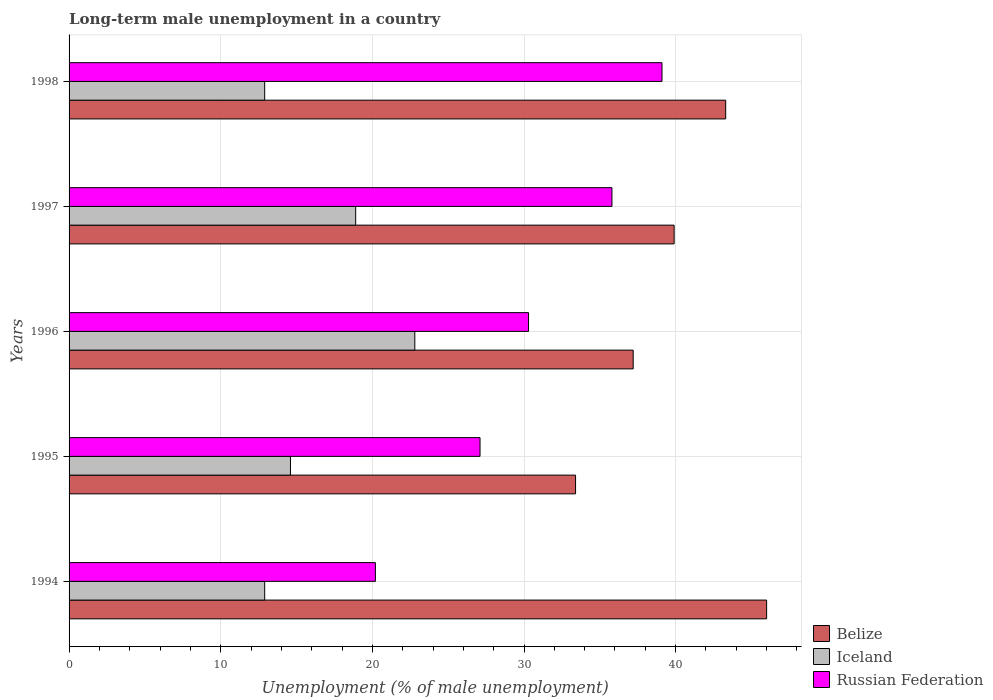How many different coloured bars are there?
Keep it short and to the point. 3. Are the number of bars per tick equal to the number of legend labels?
Offer a terse response. Yes. Are the number of bars on each tick of the Y-axis equal?
Make the answer very short. Yes. How many bars are there on the 5th tick from the top?
Your answer should be compact. 3. What is the percentage of long-term unemployed male population in Belize in 1997?
Offer a very short reply. 39.9. Across all years, what is the maximum percentage of long-term unemployed male population in Russian Federation?
Offer a very short reply. 39.1. Across all years, what is the minimum percentage of long-term unemployed male population in Iceland?
Give a very brief answer. 12.9. In which year was the percentage of long-term unemployed male population in Iceland maximum?
Provide a succinct answer. 1996. What is the total percentage of long-term unemployed male population in Iceland in the graph?
Your response must be concise. 82.1. What is the difference between the percentage of long-term unemployed male population in Russian Federation in 1994 and that in 1995?
Provide a succinct answer. -6.9. What is the difference between the percentage of long-term unemployed male population in Belize in 1994 and the percentage of long-term unemployed male population in Russian Federation in 1995?
Provide a succinct answer. 18.9. What is the average percentage of long-term unemployed male population in Belize per year?
Offer a terse response. 39.96. In the year 1994, what is the difference between the percentage of long-term unemployed male population in Belize and percentage of long-term unemployed male population in Russian Federation?
Offer a very short reply. 25.8. In how many years, is the percentage of long-term unemployed male population in Belize greater than 26 %?
Offer a terse response. 5. What is the ratio of the percentage of long-term unemployed male population in Belize in 1994 to that in 1995?
Keep it short and to the point. 1.38. Is the percentage of long-term unemployed male population in Iceland in 1994 less than that in 1998?
Provide a short and direct response. No. Is the difference between the percentage of long-term unemployed male population in Belize in 1996 and 1998 greater than the difference between the percentage of long-term unemployed male population in Russian Federation in 1996 and 1998?
Offer a terse response. Yes. What is the difference between the highest and the second highest percentage of long-term unemployed male population in Iceland?
Provide a succinct answer. 3.9. What is the difference between the highest and the lowest percentage of long-term unemployed male population in Belize?
Keep it short and to the point. 12.6. In how many years, is the percentage of long-term unemployed male population in Iceland greater than the average percentage of long-term unemployed male population in Iceland taken over all years?
Provide a succinct answer. 2. Is the sum of the percentage of long-term unemployed male population in Iceland in 1996 and 1997 greater than the maximum percentage of long-term unemployed male population in Russian Federation across all years?
Make the answer very short. Yes. What does the 1st bar from the top in 1997 represents?
Your answer should be compact. Russian Federation. Is it the case that in every year, the sum of the percentage of long-term unemployed male population in Belize and percentage of long-term unemployed male population in Russian Federation is greater than the percentage of long-term unemployed male population in Iceland?
Your answer should be very brief. Yes. Are all the bars in the graph horizontal?
Ensure brevity in your answer.  Yes. How many years are there in the graph?
Offer a terse response. 5. Does the graph contain any zero values?
Your answer should be compact. No. Where does the legend appear in the graph?
Keep it short and to the point. Bottom right. What is the title of the graph?
Provide a short and direct response. Long-term male unemployment in a country. Does "Guam" appear as one of the legend labels in the graph?
Provide a succinct answer. No. What is the label or title of the X-axis?
Provide a short and direct response. Unemployment (% of male unemployment). What is the label or title of the Y-axis?
Give a very brief answer. Years. What is the Unemployment (% of male unemployment) of Belize in 1994?
Offer a terse response. 46. What is the Unemployment (% of male unemployment) in Iceland in 1994?
Your answer should be very brief. 12.9. What is the Unemployment (% of male unemployment) in Russian Federation in 1994?
Offer a very short reply. 20.2. What is the Unemployment (% of male unemployment) in Belize in 1995?
Offer a very short reply. 33.4. What is the Unemployment (% of male unemployment) of Iceland in 1995?
Keep it short and to the point. 14.6. What is the Unemployment (% of male unemployment) in Russian Federation in 1995?
Provide a succinct answer. 27.1. What is the Unemployment (% of male unemployment) of Belize in 1996?
Your answer should be compact. 37.2. What is the Unemployment (% of male unemployment) of Iceland in 1996?
Offer a very short reply. 22.8. What is the Unemployment (% of male unemployment) in Russian Federation in 1996?
Keep it short and to the point. 30.3. What is the Unemployment (% of male unemployment) in Belize in 1997?
Make the answer very short. 39.9. What is the Unemployment (% of male unemployment) of Iceland in 1997?
Offer a terse response. 18.9. What is the Unemployment (% of male unemployment) of Russian Federation in 1997?
Your answer should be very brief. 35.8. What is the Unemployment (% of male unemployment) of Belize in 1998?
Ensure brevity in your answer.  43.3. What is the Unemployment (% of male unemployment) in Iceland in 1998?
Provide a short and direct response. 12.9. What is the Unemployment (% of male unemployment) in Russian Federation in 1998?
Make the answer very short. 39.1. Across all years, what is the maximum Unemployment (% of male unemployment) in Belize?
Keep it short and to the point. 46. Across all years, what is the maximum Unemployment (% of male unemployment) in Iceland?
Offer a very short reply. 22.8. Across all years, what is the maximum Unemployment (% of male unemployment) in Russian Federation?
Keep it short and to the point. 39.1. Across all years, what is the minimum Unemployment (% of male unemployment) in Belize?
Offer a very short reply. 33.4. Across all years, what is the minimum Unemployment (% of male unemployment) in Iceland?
Ensure brevity in your answer.  12.9. Across all years, what is the minimum Unemployment (% of male unemployment) of Russian Federation?
Your response must be concise. 20.2. What is the total Unemployment (% of male unemployment) of Belize in the graph?
Make the answer very short. 199.8. What is the total Unemployment (% of male unemployment) in Iceland in the graph?
Provide a succinct answer. 82.1. What is the total Unemployment (% of male unemployment) of Russian Federation in the graph?
Your response must be concise. 152.5. What is the difference between the Unemployment (% of male unemployment) in Iceland in 1994 and that in 1996?
Give a very brief answer. -9.9. What is the difference between the Unemployment (% of male unemployment) of Belize in 1994 and that in 1997?
Offer a terse response. 6.1. What is the difference between the Unemployment (% of male unemployment) in Russian Federation in 1994 and that in 1997?
Keep it short and to the point. -15.6. What is the difference between the Unemployment (% of male unemployment) of Belize in 1994 and that in 1998?
Your answer should be compact. 2.7. What is the difference between the Unemployment (% of male unemployment) of Iceland in 1994 and that in 1998?
Offer a very short reply. 0. What is the difference between the Unemployment (% of male unemployment) in Russian Federation in 1994 and that in 1998?
Your response must be concise. -18.9. What is the difference between the Unemployment (% of male unemployment) of Iceland in 1995 and that in 1996?
Give a very brief answer. -8.2. What is the difference between the Unemployment (% of male unemployment) of Russian Federation in 1995 and that in 1996?
Offer a terse response. -3.2. What is the difference between the Unemployment (% of male unemployment) in Russian Federation in 1995 and that in 1998?
Offer a terse response. -12. What is the difference between the Unemployment (% of male unemployment) in Russian Federation in 1996 and that in 1997?
Give a very brief answer. -5.5. What is the difference between the Unemployment (% of male unemployment) of Belize in 1997 and that in 1998?
Keep it short and to the point. -3.4. What is the difference between the Unemployment (% of male unemployment) of Iceland in 1997 and that in 1998?
Make the answer very short. 6. What is the difference between the Unemployment (% of male unemployment) in Russian Federation in 1997 and that in 1998?
Keep it short and to the point. -3.3. What is the difference between the Unemployment (% of male unemployment) in Belize in 1994 and the Unemployment (% of male unemployment) in Iceland in 1995?
Ensure brevity in your answer.  31.4. What is the difference between the Unemployment (% of male unemployment) in Belize in 1994 and the Unemployment (% of male unemployment) in Russian Federation in 1995?
Your response must be concise. 18.9. What is the difference between the Unemployment (% of male unemployment) of Iceland in 1994 and the Unemployment (% of male unemployment) of Russian Federation in 1995?
Offer a terse response. -14.2. What is the difference between the Unemployment (% of male unemployment) of Belize in 1994 and the Unemployment (% of male unemployment) of Iceland in 1996?
Give a very brief answer. 23.2. What is the difference between the Unemployment (% of male unemployment) of Iceland in 1994 and the Unemployment (% of male unemployment) of Russian Federation in 1996?
Make the answer very short. -17.4. What is the difference between the Unemployment (% of male unemployment) of Belize in 1994 and the Unemployment (% of male unemployment) of Iceland in 1997?
Your answer should be very brief. 27.1. What is the difference between the Unemployment (% of male unemployment) in Iceland in 1994 and the Unemployment (% of male unemployment) in Russian Federation in 1997?
Give a very brief answer. -22.9. What is the difference between the Unemployment (% of male unemployment) of Belize in 1994 and the Unemployment (% of male unemployment) of Iceland in 1998?
Keep it short and to the point. 33.1. What is the difference between the Unemployment (% of male unemployment) in Belize in 1994 and the Unemployment (% of male unemployment) in Russian Federation in 1998?
Ensure brevity in your answer.  6.9. What is the difference between the Unemployment (% of male unemployment) in Iceland in 1994 and the Unemployment (% of male unemployment) in Russian Federation in 1998?
Your answer should be very brief. -26.2. What is the difference between the Unemployment (% of male unemployment) in Belize in 1995 and the Unemployment (% of male unemployment) in Iceland in 1996?
Your response must be concise. 10.6. What is the difference between the Unemployment (% of male unemployment) in Iceland in 1995 and the Unemployment (% of male unemployment) in Russian Federation in 1996?
Your response must be concise. -15.7. What is the difference between the Unemployment (% of male unemployment) of Belize in 1995 and the Unemployment (% of male unemployment) of Russian Federation in 1997?
Ensure brevity in your answer.  -2.4. What is the difference between the Unemployment (% of male unemployment) in Iceland in 1995 and the Unemployment (% of male unemployment) in Russian Federation in 1997?
Your answer should be compact. -21.2. What is the difference between the Unemployment (% of male unemployment) of Belize in 1995 and the Unemployment (% of male unemployment) of Russian Federation in 1998?
Provide a short and direct response. -5.7. What is the difference between the Unemployment (% of male unemployment) in Iceland in 1995 and the Unemployment (% of male unemployment) in Russian Federation in 1998?
Make the answer very short. -24.5. What is the difference between the Unemployment (% of male unemployment) of Iceland in 1996 and the Unemployment (% of male unemployment) of Russian Federation in 1997?
Offer a terse response. -13. What is the difference between the Unemployment (% of male unemployment) in Belize in 1996 and the Unemployment (% of male unemployment) in Iceland in 1998?
Your response must be concise. 24.3. What is the difference between the Unemployment (% of male unemployment) in Belize in 1996 and the Unemployment (% of male unemployment) in Russian Federation in 1998?
Make the answer very short. -1.9. What is the difference between the Unemployment (% of male unemployment) in Iceland in 1996 and the Unemployment (% of male unemployment) in Russian Federation in 1998?
Your answer should be very brief. -16.3. What is the difference between the Unemployment (% of male unemployment) in Belize in 1997 and the Unemployment (% of male unemployment) in Iceland in 1998?
Keep it short and to the point. 27. What is the difference between the Unemployment (% of male unemployment) of Belize in 1997 and the Unemployment (% of male unemployment) of Russian Federation in 1998?
Provide a succinct answer. 0.8. What is the difference between the Unemployment (% of male unemployment) of Iceland in 1997 and the Unemployment (% of male unemployment) of Russian Federation in 1998?
Keep it short and to the point. -20.2. What is the average Unemployment (% of male unemployment) in Belize per year?
Provide a succinct answer. 39.96. What is the average Unemployment (% of male unemployment) of Iceland per year?
Make the answer very short. 16.42. What is the average Unemployment (% of male unemployment) of Russian Federation per year?
Provide a succinct answer. 30.5. In the year 1994, what is the difference between the Unemployment (% of male unemployment) in Belize and Unemployment (% of male unemployment) in Iceland?
Ensure brevity in your answer.  33.1. In the year 1994, what is the difference between the Unemployment (% of male unemployment) of Belize and Unemployment (% of male unemployment) of Russian Federation?
Ensure brevity in your answer.  25.8. In the year 1995, what is the difference between the Unemployment (% of male unemployment) in Belize and Unemployment (% of male unemployment) in Iceland?
Your answer should be compact. 18.8. In the year 1995, what is the difference between the Unemployment (% of male unemployment) in Belize and Unemployment (% of male unemployment) in Russian Federation?
Your answer should be compact. 6.3. In the year 1995, what is the difference between the Unemployment (% of male unemployment) of Iceland and Unemployment (% of male unemployment) of Russian Federation?
Provide a succinct answer. -12.5. In the year 1996, what is the difference between the Unemployment (% of male unemployment) in Belize and Unemployment (% of male unemployment) in Iceland?
Your response must be concise. 14.4. In the year 1996, what is the difference between the Unemployment (% of male unemployment) of Belize and Unemployment (% of male unemployment) of Russian Federation?
Make the answer very short. 6.9. In the year 1996, what is the difference between the Unemployment (% of male unemployment) in Iceland and Unemployment (% of male unemployment) in Russian Federation?
Offer a very short reply. -7.5. In the year 1997, what is the difference between the Unemployment (% of male unemployment) in Belize and Unemployment (% of male unemployment) in Iceland?
Provide a short and direct response. 21. In the year 1997, what is the difference between the Unemployment (% of male unemployment) of Belize and Unemployment (% of male unemployment) of Russian Federation?
Provide a short and direct response. 4.1. In the year 1997, what is the difference between the Unemployment (% of male unemployment) of Iceland and Unemployment (% of male unemployment) of Russian Federation?
Your answer should be very brief. -16.9. In the year 1998, what is the difference between the Unemployment (% of male unemployment) in Belize and Unemployment (% of male unemployment) in Iceland?
Make the answer very short. 30.4. In the year 1998, what is the difference between the Unemployment (% of male unemployment) in Iceland and Unemployment (% of male unemployment) in Russian Federation?
Your answer should be very brief. -26.2. What is the ratio of the Unemployment (% of male unemployment) of Belize in 1994 to that in 1995?
Keep it short and to the point. 1.38. What is the ratio of the Unemployment (% of male unemployment) in Iceland in 1994 to that in 1995?
Keep it short and to the point. 0.88. What is the ratio of the Unemployment (% of male unemployment) of Russian Federation in 1994 to that in 1995?
Offer a very short reply. 0.75. What is the ratio of the Unemployment (% of male unemployment) of Belize in 1994 to that in 1996?
Keep it short and to the point. 1.24. What is the ratio of the Unemployment (% of male unemployment) in Iceland in 1994 to that in 1996?
Offer a very short reply. 0.57. What is the ratio of the Unemployment (% of male unemployment) of Belize in 1994 to that in 1997?
Your answer should be very brief. 1.15. What is the ratio of the Unemployment (% of male unemployment) of Iceland in 1994 to that in 1997?
Your answer should be compact. 0.68. What is the ratio of the Unemployment (% of male unemployment) in Russian Federation in 1994 to that in 1997?
Give a very brief answer. 0.56. What is the ratio of the Unemployment (% of male unemployment) of Belize in 1994 to that in 1998?
Make the answer very short. 1.06. What is the ratio of the Unemployment (% of male unemployment) in Russian Federation in 1994 to that in 1998?
Offer a very short reply. 0.52. What is the ratio of the Unemployment (% of male unemployment) of Belize in 1995 to that in 1996?
Keep it short and to the point. 0.9. What is the ratio of the Unemployment (% of male unemployment) in Iceland in 1995 to that in 1996?
Keep it short and to the point. 0.64. What is the ratio of the Unemployment (% of male unemployment) in Russian Federation in 1995 to that in 1996?
Ensure brevity in your answer.  0.89. What is the ratio of the Unemployment (% of male unemployment) in Belize in 1995 to that in 1997?
Provide a succinct answer. 0.84. What is the ratio of the Unemployment (% of male unemployment) of Iceland in 1995 to that in 1997?
Make the answer very short. 0.77. What is the ratio of the Unemployment (% of male unemployment) of Russian Federation in 1995 to that in 1997?
Ensure brevity in your answer.  0.76. What is the ratio of the Unemployment (% of male unemployment) of Belize in 1995 to that in 1998?
Provide a succinct answer. 0.77. What is the ratio of the Unemployment (% of male unemployment) of Iceland in 1995 to that in 1998?
Make the answer very short. 1.13. What is the ratio of the Unemployment (% of male unemployment) of Russian Federation in 1995 to that in 1998?
Provide a succinct answer. 0.69. What is the ratio of the Unemployment (% of male unemployment) of Belize in 1996 to that in 1997?
Make the answer very short. 0.93. What is the ratio of the Unemployment (% of male unemployment) of Iceland in 1996 to that in 1997?
Make the answer very short. 1.21. What is the ratio of the Unemployment (% of male unemployment) in Russian Federation in 1996 to that in 1997?
Give a very brief answer. 0.85. What is the ratio of the Unemployment (% of male unemployment) of Belize in 1996 to that in 1998?
Ensure brevity in your answer.  0.86. What is the ratio of the Unemployment (% of male unemployment) of Iceland in 1996 to that in 1998?
Your answer should be compact. 1.77. What is the ratio of the Unemployment (% of male unemployment) in Russian Federation in 1996 to that in 1998?
Give a very brief answer. 0.77. What is the ratio of the Unemployment (% of male unemployment) in Belize in 1997 to that in 1998?
Your response must be concise. 0.92. What is the ratio of the Unemployment (% of male unemployment) of Iceland in 1997 to that in 1998?
Your answer should be very brief. 1.47. What is the ratio of the Unemployment (% of male unemployment) of Russian Federation in 1997 to that in 1998?
Your response must be concise. 0.92. What is the difference between the highest and the second highest Unemployment (% of male unemployment) of Belize?
Give a very brief answer. 2.7. What is the difference between the highest and the second highest Unemployment (% of male unemployment) of Iceland?
Offer a terse response. 3.9. What is the difference between the highest and the second highest Unemployment (% of male unemployment) of Russian Federation?
Provide a short and direct response. 3.3. What is the difference between the highest and the lowest Unemployment (% of male unemployment) of Belize?
Ensure brevity in your answer.  12.6. What is the difference between the highest and the lowest Unemployment (% of male unemployment) in Iceland?
Make the answer very short. 9.9. 